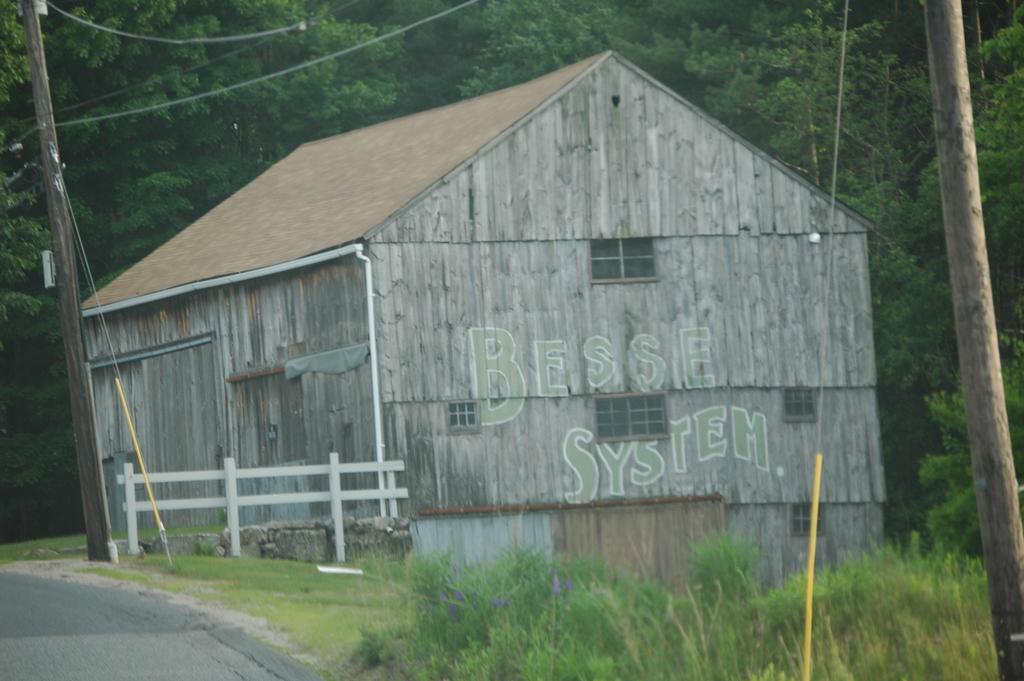What is the main feature of the image? There is a road in the image. What else can be seen along the road? There is a fence, poles, a house with windows, plants, wires, and trees visible in the background. Can you describe the house in the image? The house has windows and is surrounded by other elements such as plants and wires. What type of vegetation is present in the image? There are plants and trees visible in the image. How does the cheese increase in value over time in the image? There is no cheese present in the image, so it cannot be determined how its value might increase over time. 